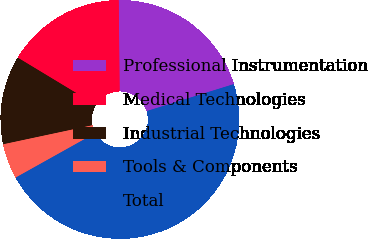Convert chart. <chart><loc_0><loc_0><loc_500><loc_500><pie_chart><fcel>Professional Instrumentation<fcel>Medical Technologies<fcel>Industrial Technologies<fcel>Tools & Components<fcel>Total<nl><fcel>20.38%<fcel>16.19%<fcel>12.0%<fcel>4.76%<fcel>46.67%<nl></chart> 